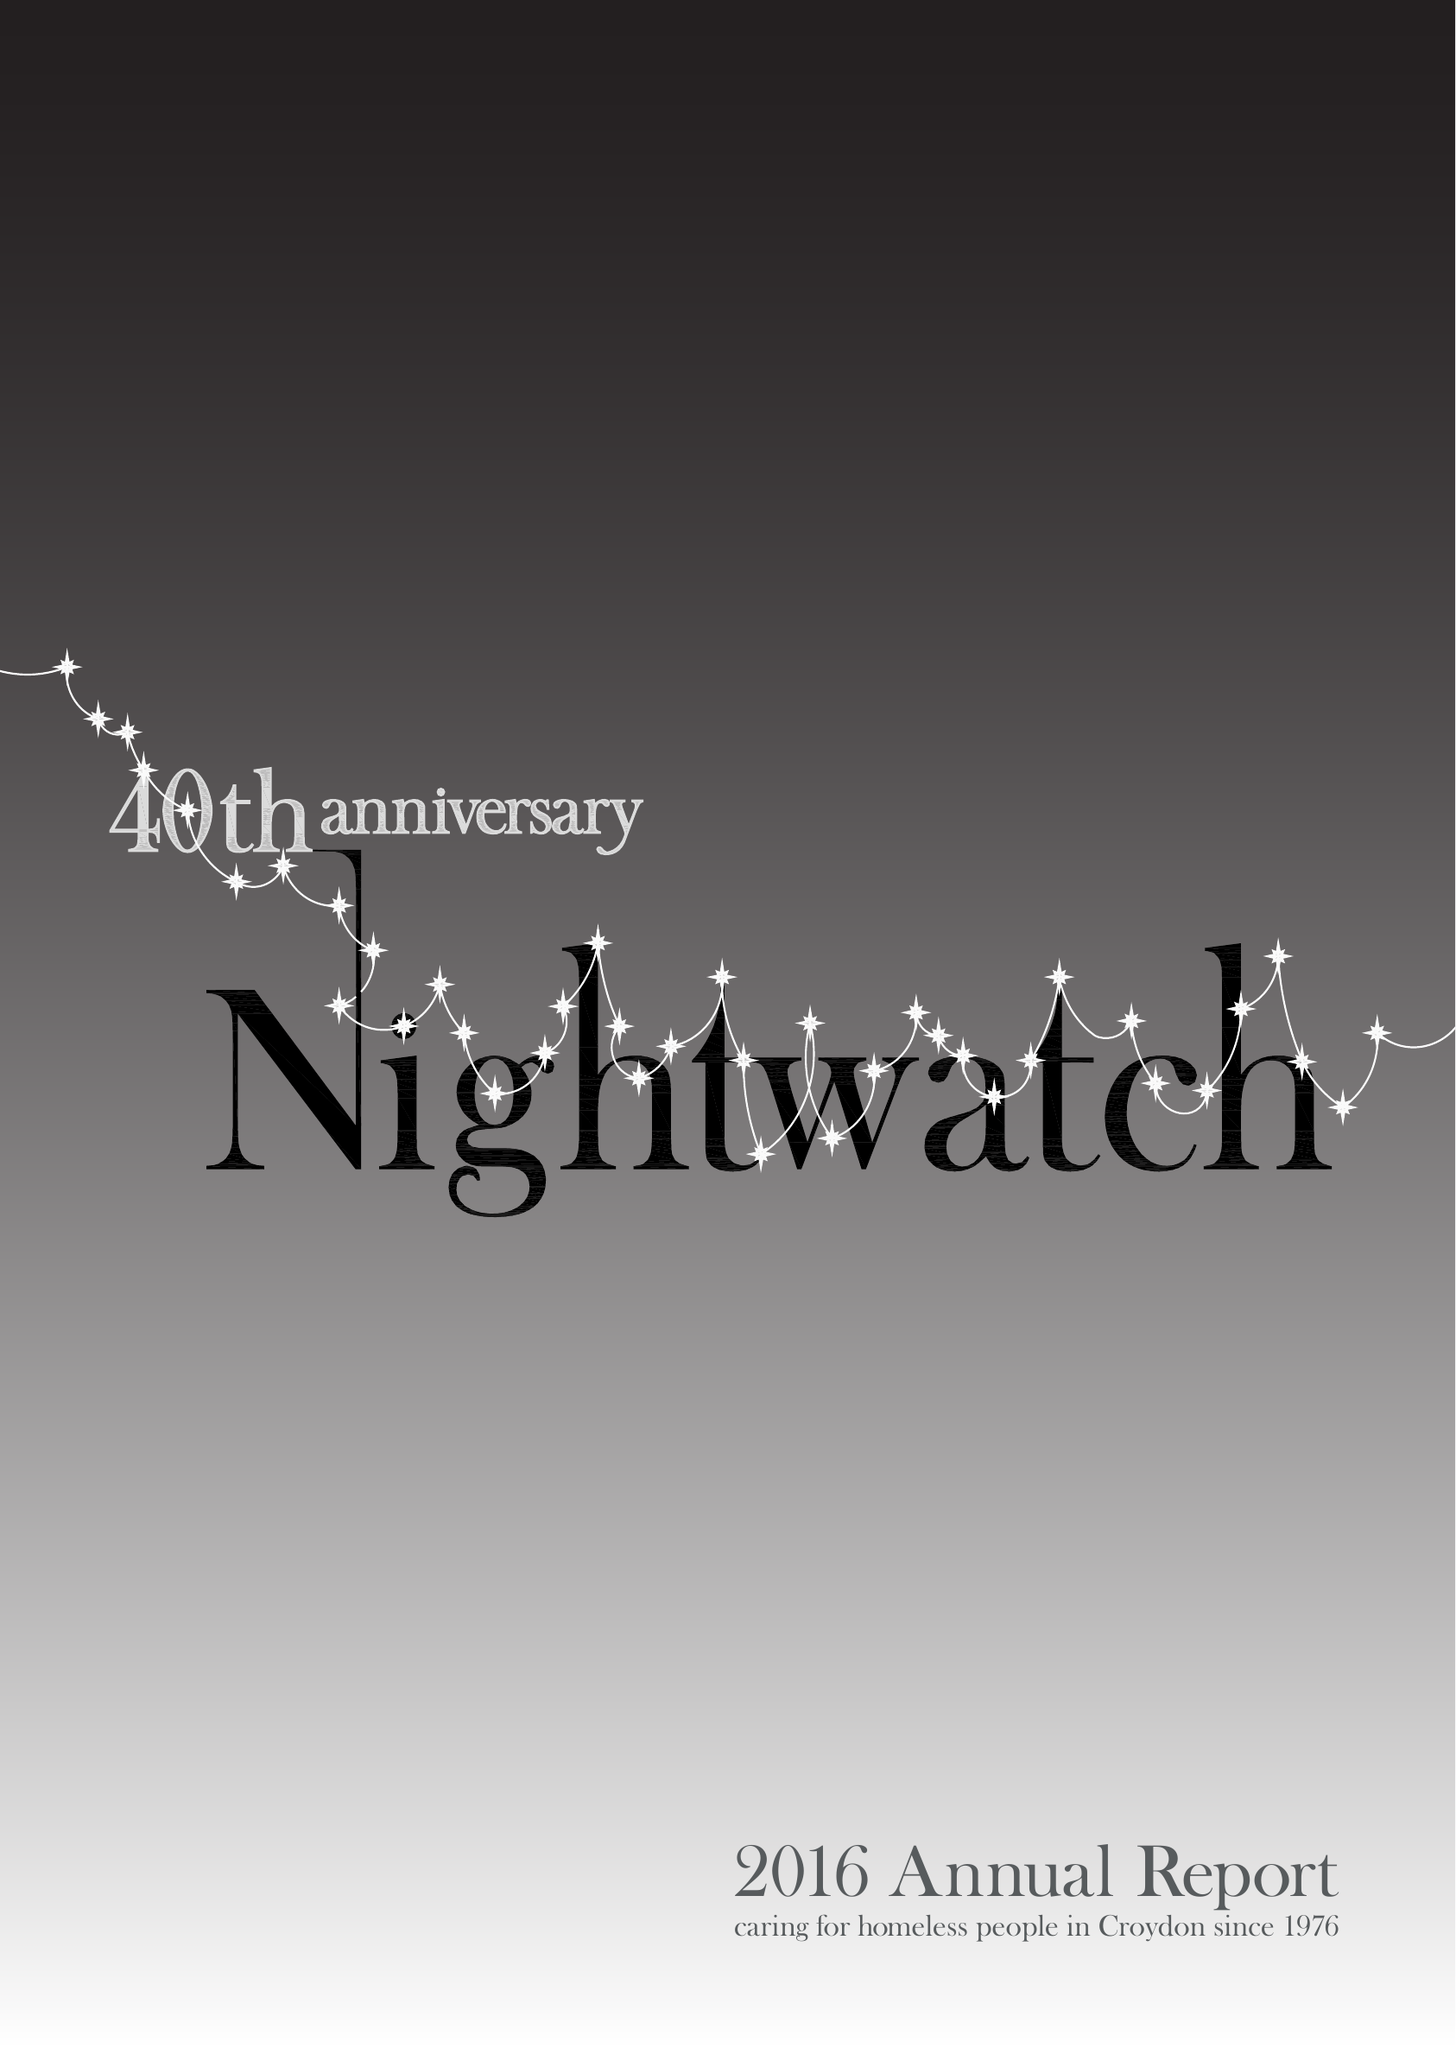What is the value for the spending_annually_in_british_pounds?
Answer the question using a single word or phrase. 54856.00 